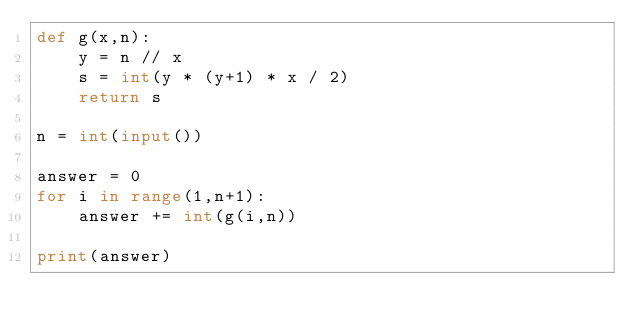<code> <loc_0><loc_0><loc_500><loc_500><_Python_>def g(x,n):
    y = n // x
    s = int(y * (y+1) * x / 2)
    return s

n = int(input())

answer = 0
for i in range(1,n+1):
    answer += int(g(i,n))

print(answer)</code> 